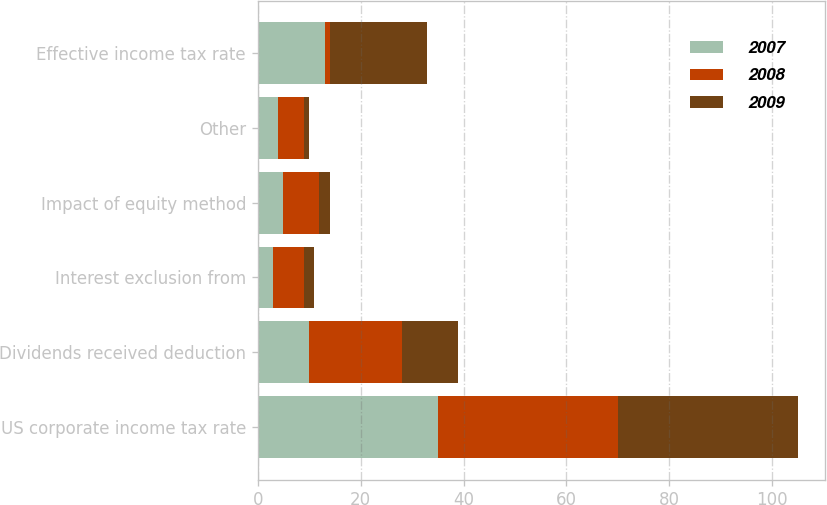Convert chart to OTSL. <chart><loc_0><loc_0><loc_500><loc_500><stacked_bar_chart><ecel><fcel>US corporate income tax rate<fcel>Dividends received deduction<fcel>Interest exclusion from<fcel>Impact of equity method<fcel>Other<fcel>Effective income tax rate<nl><fcel>2007<fcel>35<fcel>10<fcel>3<fcel>5<fcel>4<fcel>13<nl><fcel>2008<fcel>35<fcel>18<fcel>6<fcel>7<fcel>5<fcel>1<nl><fcel>2009<fcel>35<fcel>11<fcel>2<fcel>2<fcel>1<fcel>19<nl></chart> 